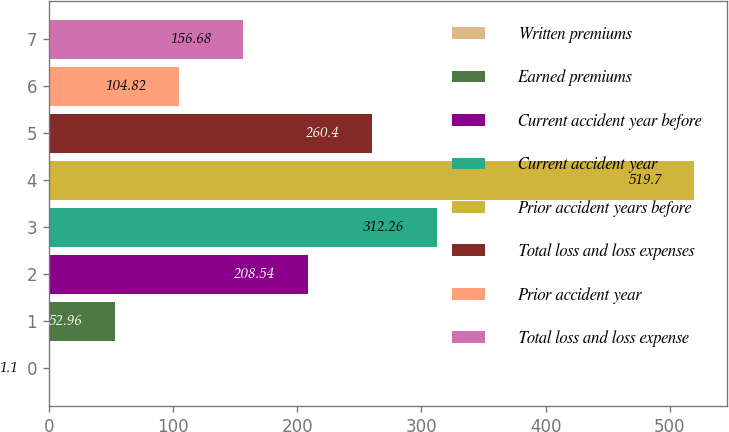<chart> <loc_0><loc_0><loc_500><loc_500><bar_chart><fcel>Written premiums<fcel>Earned premiums<fcel>Current accident year before<fcel>Current accident year<fcel>Prior accident years before<fcel>Total loss and loss expenses<fcel>Prior accident year<fcel>Total loss and loss expense<nl><fcel>1.1<fcel>52.96<fcel>208.54<fcel>312.26<fcel>519.7<fcel>260.4<fcel>104.82<fcel>156.68<nl></chart> 